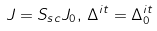Convert formula to latex. <formula><loc_0><loc_0><loc_500><loc_500>J = S _ { s c } J _ { 0 } , \, \Delta ^ { i t } = \Delta _ { 0 } ^ { i t }</formula> 